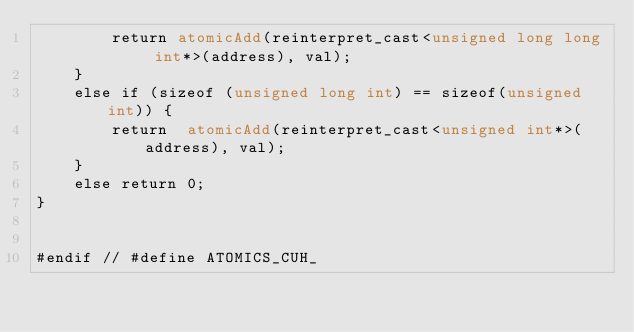Convert code to text. <code><loc_0><loc_0><loc_500><loc_500><_Cuda_>        return atomicAdd(reinterpret_cast<unsigned long long int*>(address), val);
    }
    else if (sizeof (unsigned long int) == sizeof(unsigned int)) {
        return  atomicAdd(reinterpret_cast<unsigned int*>(address), val);
    }
    else return 0;
}


#endif // #define ATOMICS_CUH_
</code> 